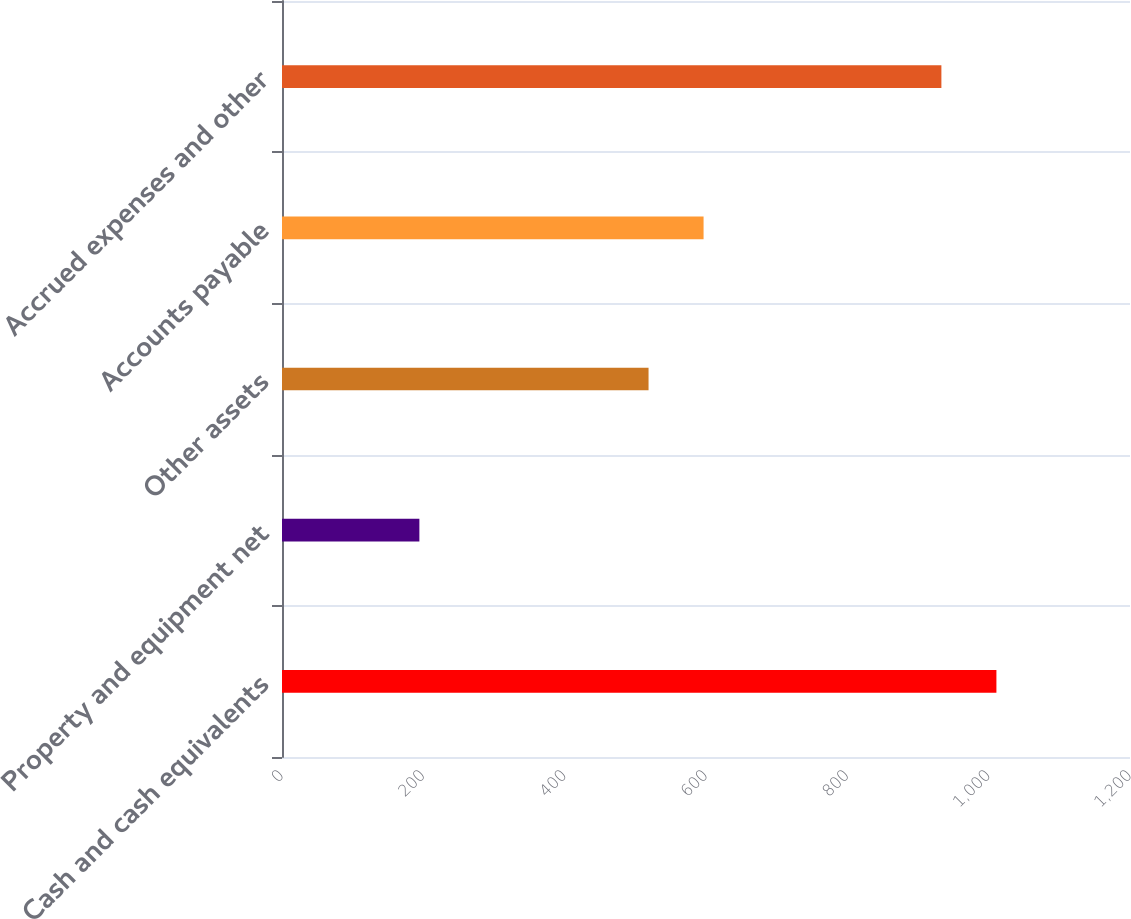Convert chart to OTSL. <chart><loc_0><loc_0><loc_500><loc_500><bar_chart><fcel>Cash and cash equivalents<fcel>Property and equipment net<fcel>Other assets<fcel>Accounts payable<fcel>Accrued expenses and other<nl><fcel>1010.96<fcel>194.4<fcel>518.7<fcel>596.56<fcel>933.1<nl></chart> 